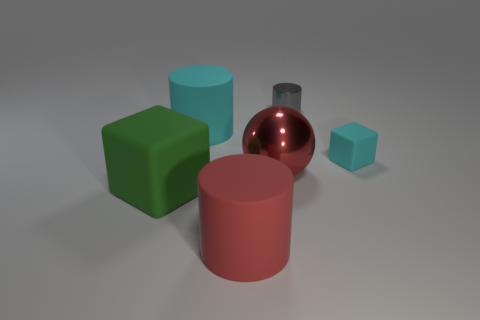Is the metallic cylinder the same size as the red rubber object?
Ensure brevity in your answer.  No. There is a large object that is made of the same material as the small gray cylinder; what shape is it?
Your answer should be very brief. Sphere. How many other things are the same shape as the red matte object?
Provide a short and direct response. 2. The cyan thing to the left of the matte cube that is right of the big rubber cylinder in front of the cyan matte block is what shape?
Your answer should be very brief. Cylinder. How many cubes are small gray objects or green matte things?
Make the answer very short. 1. Is there a large matte object in front of the cyan matte object to the right of the gray thing?
Keep it short and to the point. Yes. There is a tiny rubber object; does it have the same shape as the big object that is left of the large cyan matte object?
Give a very brief answer. Yes. How many other things are there of the same size as the cyan rubber cube?
Keep it short and to the point. 1. How many red objects are either small matte spheres or metal balls?
Offer a terse response. 1. How many things are both in front of the metal cylinder and behind the big ball?
Your answer should be very brief. 2. 